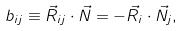Convert formula to latex. <formula><loc_0><loc_0><loc_500><loc_500>b _ { i j } \equiv \vec { R } _ { i j } \cdot \vec { N } = - \vec { R } _ { i } \cdot \vec { N } _ { j } ,</formula> 